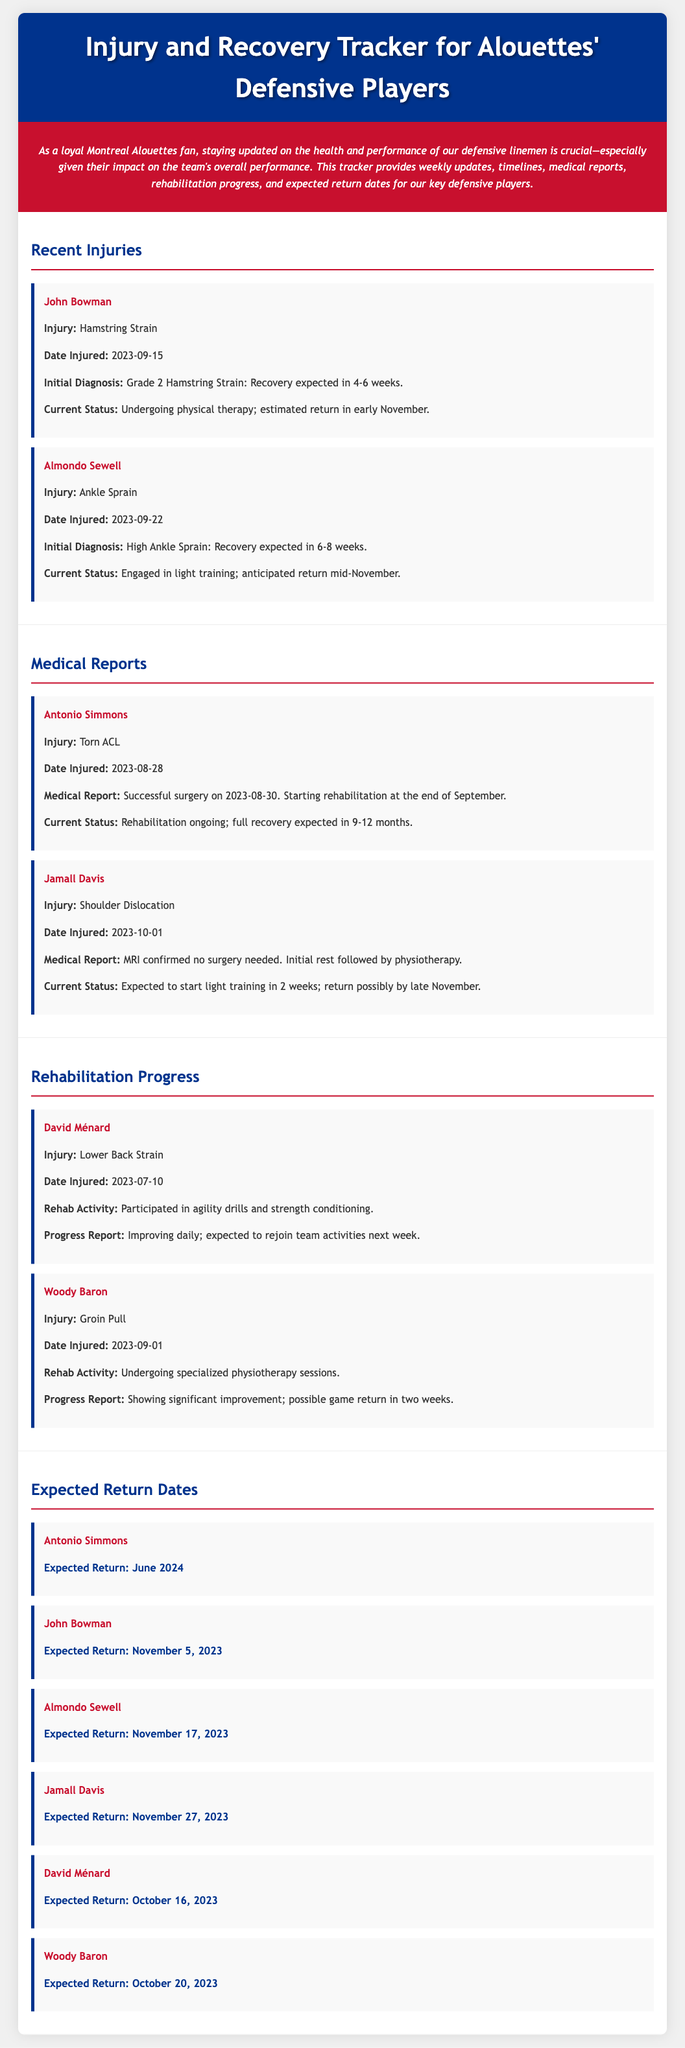What is John Bowman's injury? The document lists John Bowman's injury as a Hamstring Strain.
Answer: Hamstring Strain When did Almondo Sewell get injured? The document states that Almondo Sewell was injured on September 22, 2023.
Answer: September 22, 2023 What is the expected return date for David Ménard? The expected return date for David Ménard is provided in the document as October 16, 2023.
Answer: October 16, 2023 How long is Antonio Simmons' rehabilitation expected to take? The document mentions that full recovery for Antonio Simmons is expected in 9-12 months.
Answer: 9-12 months What type of injury is Jamall Davis recovering from? The document indicates that Jamall Davis is recovering from a Shoulder Dislocation.
Answer: Shoulder Dislocation What kind of therapy is John Bowman currently undergoing? The document states that John Bowman is undergoing physical therapy.
Answer: Physical therapy Which player is expected to return on November 17, 2023? The document lists Almondo Sewell as the player expected to return on that date.
Answer: Almondo Sewell What rehabilitation activity is Woody Baron engaged in? According to the document, Woody Baron is undergoing specialized physiotherapy sessions.
Answer: Specialized physiotherapy sessions What was the date of Antonio Simmons' injury? The document provides the date of Antonio Simmons' injury as August 28, 2023.
Answer: August 28, 2023 